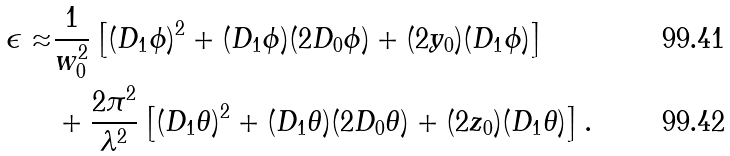Convert formula to latex. <formula><loc_0><loc_0><loc_500><loc_500>\epsilon \approx & \frac { 1 } { w _ { 0 } ^ { 2 } } \left [ ( D _ { 1 } \phi ) ^ { 2 } + ( D _ { 1 } \phi ) ( 2 D _ { 0 } \phi ) + ( 2 y _ { 0 } ) ( D _ { 1 } \phi ) \right ] \\ & + \frac { 2 \pi ^ { 2 } } { \lambda ^ { 2 } } \left [ ( D _ { 1 } \theta ) ^ { 2 } + ( D _ { 1 } \theta ) ( 2 D _ { 0 } \theta ) + ( 2 z _ { 0 } ) ( D _ { 1 } \theta ) \right ] .</formula> 